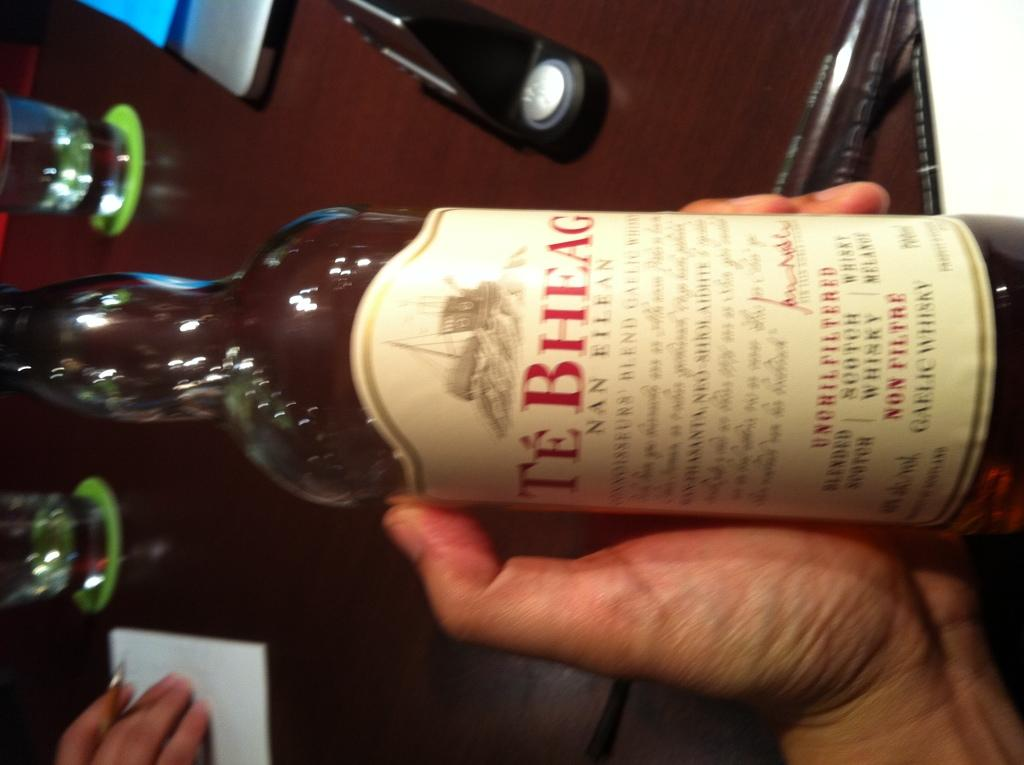<image>
Offer a succinct explanation of the picture presented. Someone holds a bottle of Té Bheag Gaelic whiskey. 